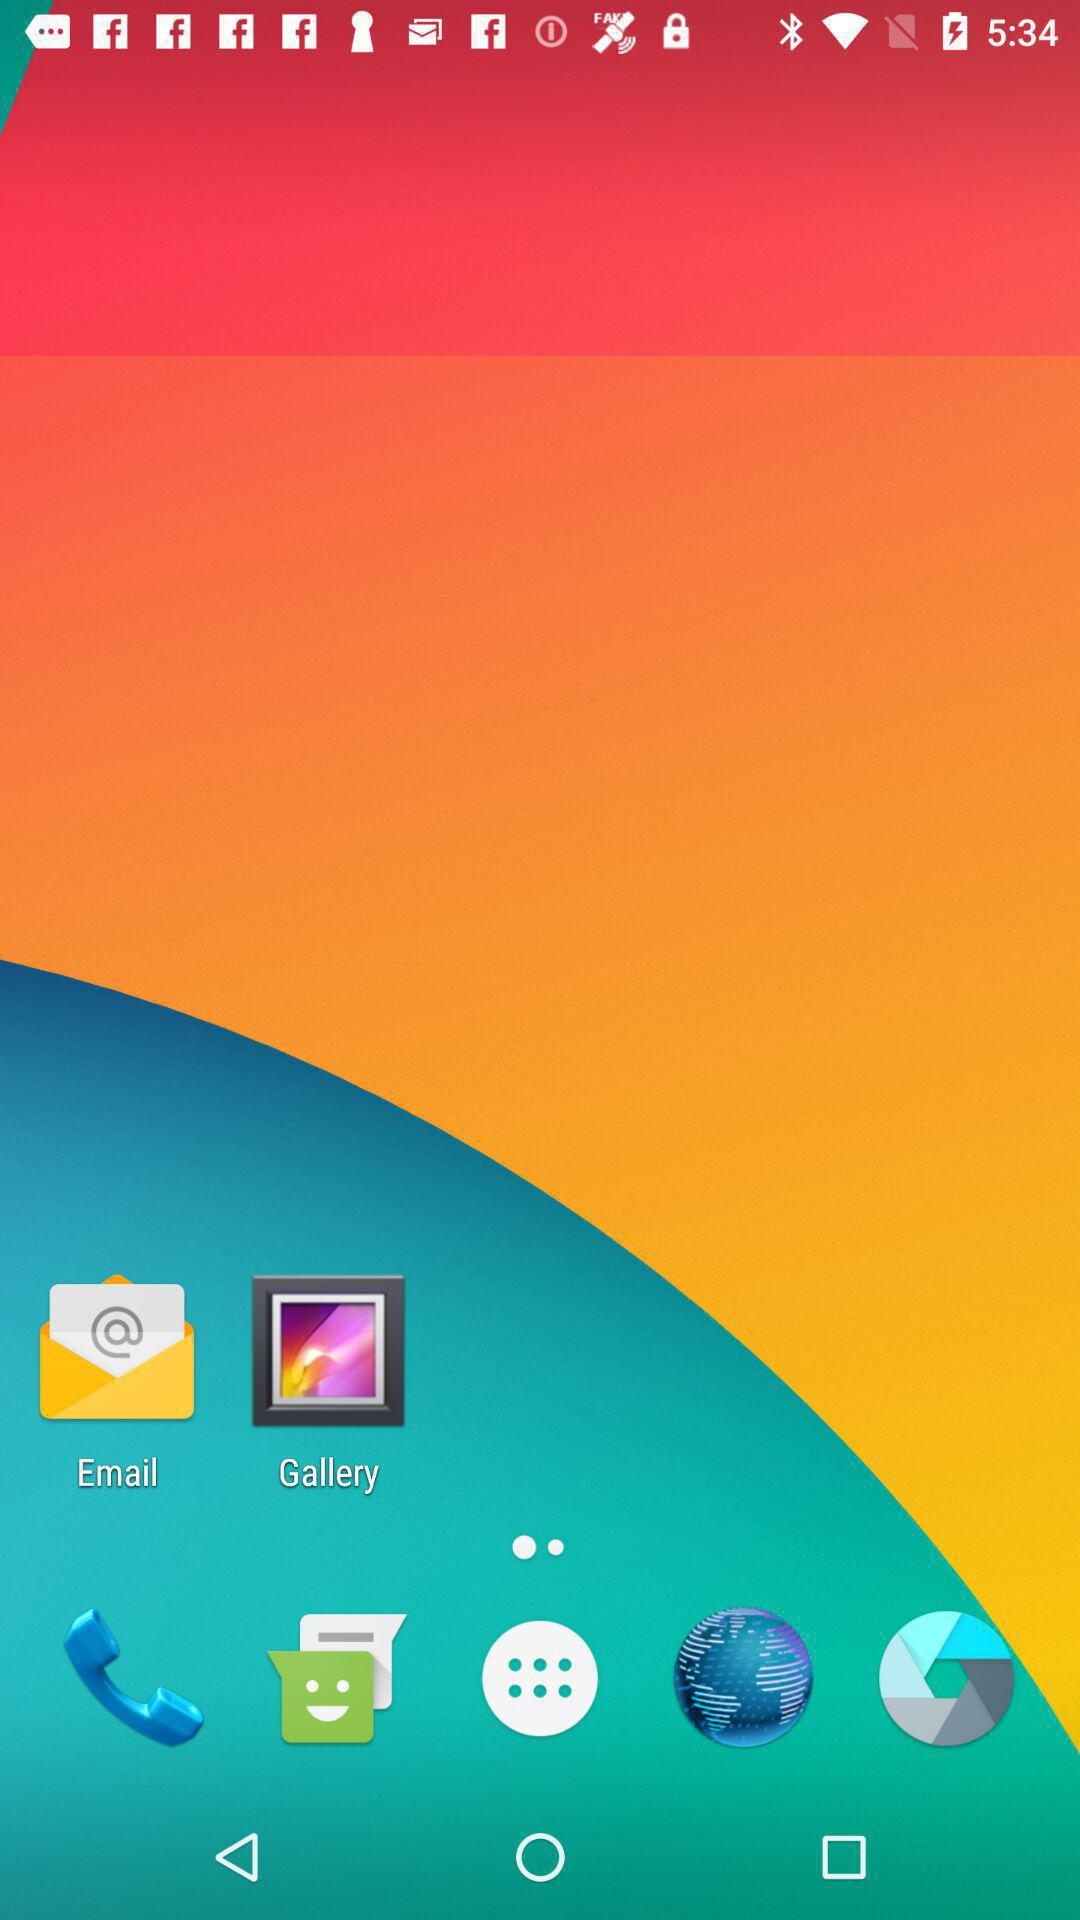What is the name of the application? The name of the application is "mPAY". 